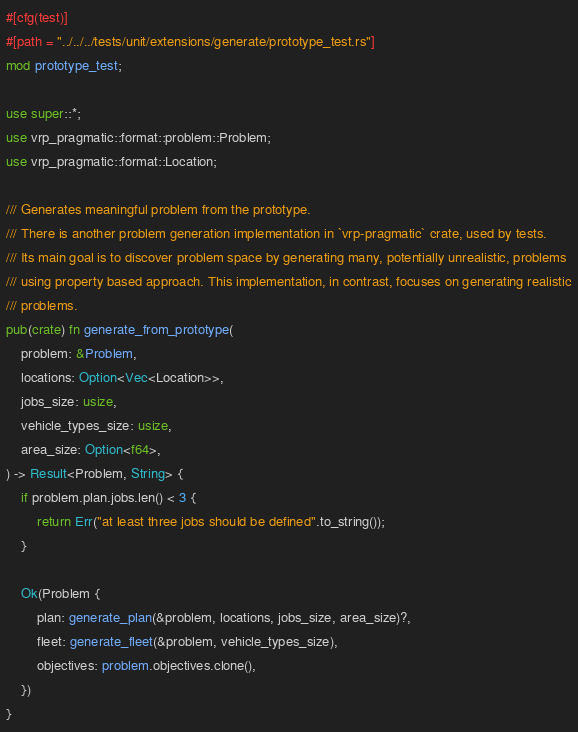<code> <loc_0><loc_0><loc_500><loc_500><_Rust_>#[cfg(test)]
#[path = "../../../tests/unit/extensions/generate/prototype_test.rs"]
mod prototype_test;

use super::*;
use vrp_pragmatic::format::problem::Problem;
use vrp_pragmatic::format::Location;

/// Generates meaningful problem from the prototype.
/// There is another problem generation implementation in `vrp-pragmatic` crate, used by tests.
/// Its main goal is to discover problem space by generating many, potentially unrealistic, problems
/// using property based approach. This implementation, in contrast, focuses on generating realistic
/// problems.
pub(crate) fn generate_from_prototype(
    problem: &Problem,
    locations: Option<Vec<Location>>,
    jobs_size: usize,
    vehicle_types_size: usize,
    area_size: Option<f64>,
) -> Result<Problem, String> {
    if problem.plan.jobs.len() < 3 {
        return Err("at least three jobs should be defined".to_string());
    }

    Ok(Problem {
        plan: generate_plan(&problem, locations, jobs_size, area_size)?,
        fleet: generate_fleet(&problem, vehicle_types_size),
        objectives: problem.objectives.clone(),
    })
}
</code> 